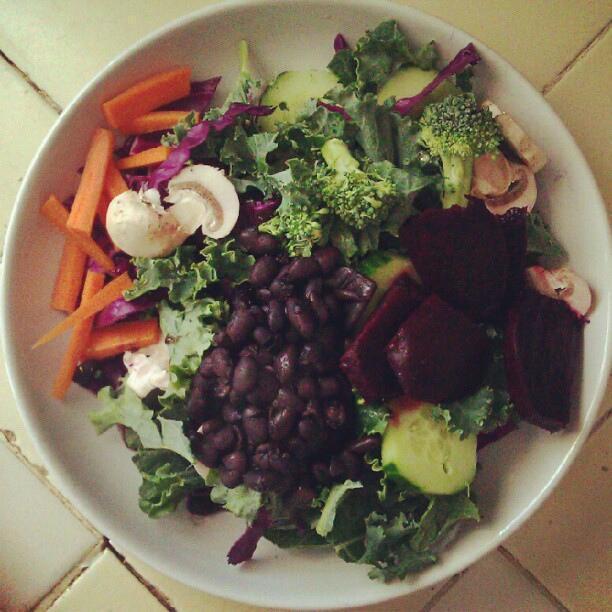What are the sliced red vegetables on the right side of dish called?
Select the accurate answer and provide justification: `Answer: choice
Rationale: srationale.`
Options: Red cabbage, eggplant, beets, radish. Answer: beets.
Rationale: They are burgundy vegetables. 